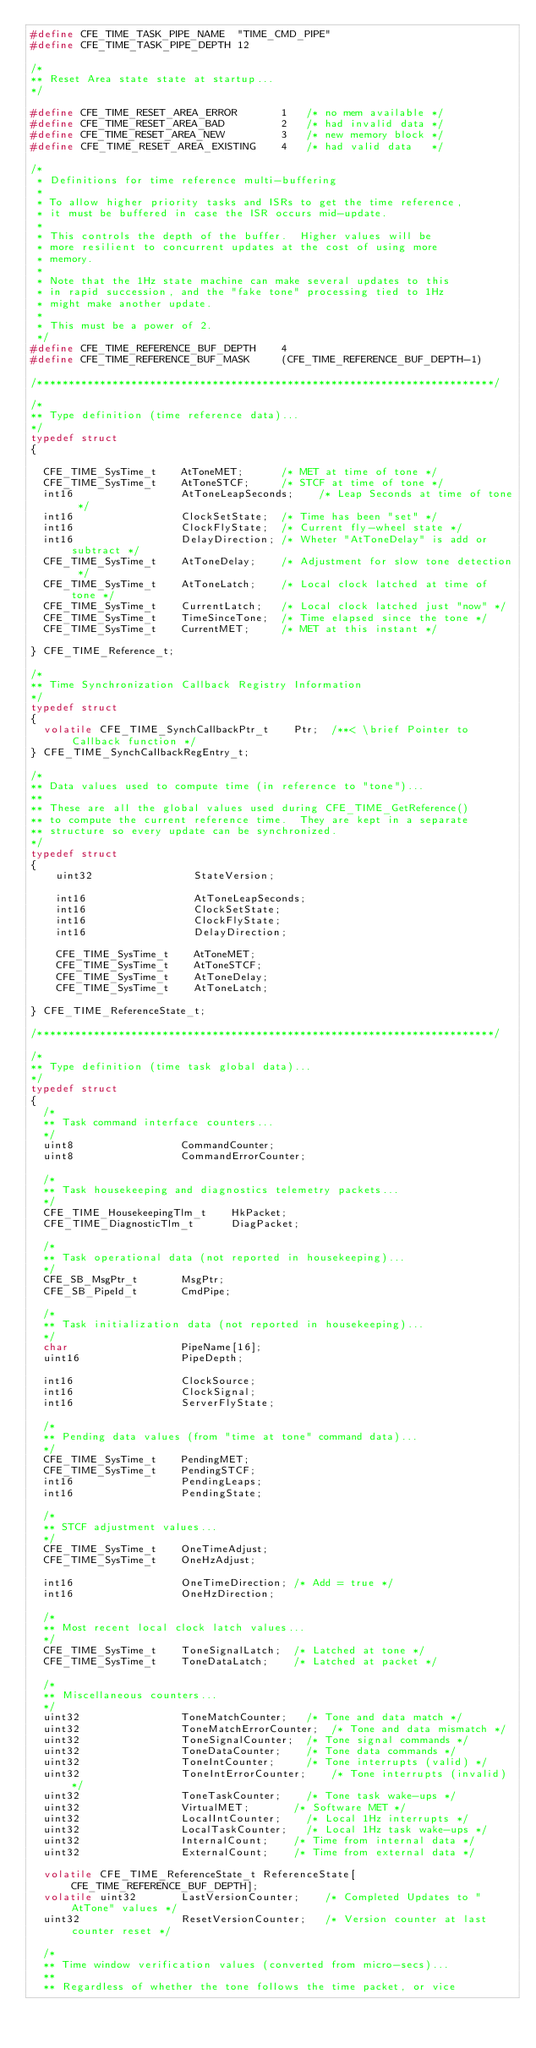<code> <loc_0><loc_0><loc_500><loc_500><_C_>#define CFE_TIME_TASK_PIPE_NAME  "TIME_CMD_PIPE"
#define CFE_TIME_TASK_PIPE_DEPTH 12

/*
** Reset Area state state at startup...
*/

#define CFE_TIME_RESET_AREA_ERROR       1   /* no mem available */
#define CFE_TIME_RESET_AREA_BAD         2   /* had invalid data */
#define CFE_TIME_RESET_AREA_NEW         3   /* new memory block */
#define CFE_TIME_RESET_AREA_EXISTING    4   /* had valid data   */

/*
 * Definitions for time reference multi-buffering
 *
 * To allow higher priority tasks and ISRs to get the time reference,
 * it must be buffered in case the ISR occurs mid-update.
 *
 * This controls the depth of the buffer.  Higher values will be
 * more resilient to concurrent updates at the cost of using more
 * memory.
 *
 * Note that the 1Hz state machine can make several updates to this
 * in rapid succession, and the "fake tone" processing tied to 1Hz
 * might make another update.
 *
 * This must be a power of 2.
 */
#define CFE_TIME_REFERENCE_BUF_DEPTH    4
#define CFE_TIME_REFERENCE_BUF_MASK     (CFE_TIME_REFERENCE_BUF_DEPTH-1)

/*************************************************************************/

/*
** Type definition (time reference data)...
*/
typedef struct
{

  CFE_TIME_SysTime_t    AtToneMET;      /* MET at time of tone */
  CFE_TIME_SysTime_t    AtToneSTCF;     /* STCF at time of tone */
  int16                 AtToneLeapSeconds;    /* Leap Seconds at time of tone */
  int16                 ClockSetState;  /* Time has been "set" */
  int16                 ClockFlyState;  /* Current fly-wheel state */
  int16                 DelayDirection; /* Wheter "AtToneDelay" is add or subtract */
  CFE_TIME_SysTime_t    AtToneDelay;    /* Adjustment for slow tone detection */
  CFE_TIME_SysTime_t    AtToneLatch;    /* Local clock latched at time of tone */
  CFE_TIME_SysTime_t    CurrentLatch;   /* Local clock latched just "now" */
  CFE_TIME_SysTime_t    TimeSinceTone;  /* Time elapsed since the tone */
  CFE_TIME_SysTime_t    CurrentMET;     /* MET at this instant */

} CFE_TIME_Reference_t;

/*
** Time Synchronization Callback Registry Information
*/
typedef struct
{
  volatile CFE_TIME_SynchCallbackPtr_t    Ptr;  /**< \brief Pointer to Callback function */
} CFE_TIME_SynchCallbackRegEntry_t;

/*
** Data values used to compute time (in reference to "tone")...
**
** These are all the global values used during CFE_TIME_GetReference()
** to compute the current reference time.  They are kept in a separate
** structure so every update can be synchronized.
*/
typedef struct
{
    uint32                StateVersion;

    int16                 AtToneLeapSeconds;
    int16                 ClockSetState;
    int16                 ClockFlyState;
    int16                 DelayDirection;

    CFE_TIME_SysTime_t    AtToneMET;
    CFE_TIME_SysTime_t    AtToneSTCF;
    CFE_TIME_SysTime_t    AtToneDelay;
    CFE_TIME_SysTime_t    AtToneLatch;

} CFE_TIME_ReferenceState_t;

/*************************************************************************/

/*
** Type definition (time task global data)...
*/
typedef struct
{
  /*
  ** Task command interface counters...
  */
  uint8                 CommandCounter;
  uint8                 CommandErrorCounter;

  /*
  ** Task housekeeping and diagnostics telemetry packets...
  */
  CFE_TIME_HousekeepingTlm_t    HkPacket;
  CFE_TIME_DiagnosticTlm_t      DiagPacket;

  /*
  ** Task operational data (not reported in housekeeping)...
  */
  CFE_SB_MsgPtr_t       MsgPtr;
  CFE_SB_PipeId_t       CmdPipe;

  /*
  ** Task initialization data (not reported in housekeeping)...
  */
  char                  PipeName[16];
  uint16                PipeDepth;

  int16                 ClockSource;
  int16                 ClockSignal;
  int16                 ServerFlyState;

  /*
  ** Pending data values (from "time at tone" command data)...
  */
  CFE_TIME_SysTime_t    PendingMET;
  CFE_TIME_SysTime_t    PendingSTCF;
  int16                 PendingLeaps;
  int16                 PendingState;

  /*
  ** STCF adjustment values...
  */
  CFE_TIME_SysTime_t    OneTimeAdjust;
  CFE_TIME_SysTime_t    OneHzAdjust;

  int16                 OneTimeDirection; /* Add = true */
  int16                 OneHzDirection;

  /*
  ** Most recent local clock latch values...
  */
  CFE_TIME_SysTime_t    ToneSignalLatch;  /* Latched at tone */
  CFE_TIME_SysTime_t    ToneDataLatch;    /* Latched at packet */

  /*
  ** Miscellaneous counters...
  */
  uint32                ToneMatchCounter;   /* Tone and data match */
  uint32                ToneMatchErrorCounter;  /* Tone and data mismatch */
  uint32                ToneSignalCounter;  /* Tone signal commands */
  uint32                ToneDataCounter;    /* Tone data commands */
  uint32                ToneIntCounter;     /* Tone interrupts (valid) */
  uint32                ToneIntErrorCounter;    /* Tone interrupts (invalid) */
  uint32                ToneTaskCounter;    /* Tone task wake-ups */
  uint32                VirtualMET;       /* Software MET */
  uint32                LocalIntCounter;    /* Local 1Hz interrupts */
  uint32                LocalTaskCounter;   /* Local 1Hz task wake-ups */
  uint32                InternalCount;    /* Time from internal data */
  uint32                ExternalCount;    /* Time from external data */

  volatile CFE_TIME_ReferenceState_t ReferenceState[CFE_TIME_REFERENCE_BUF_DEPTH];
  volatile uint32       LastVersionCounter;    /* Completed Updates to "AtTone" values */
  uint32                ResetVersionCounter;   /* Version counter at last counter reset */

  /*
  ** Time window verification values (converted from micro-secs)...
  **
  ** Regardless of whether the tone follows the time packet, or vice</code> 